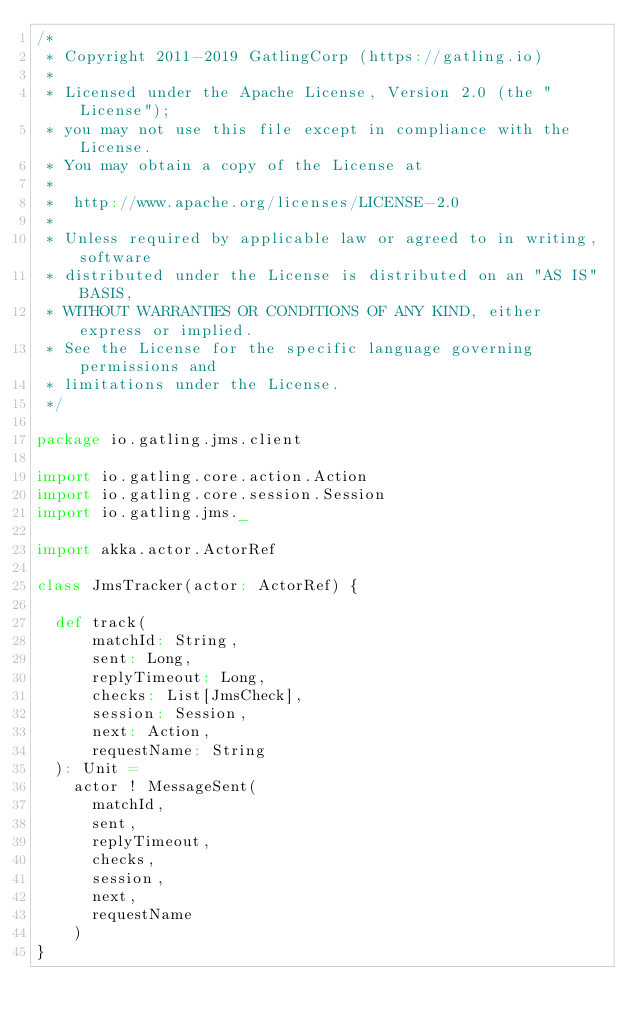<code> <loc_0><loc_0><loc_500><loc_500><_Scala_>/*
 * Copyright 2011-2019 GatlingCorp (https://gatling.io)
 *
 * Licensed under the Apache License, Version 2.0 (the "License");
 * you may not use this file except in compliance with the License.
 * You may obtain a copy of the License at
 *
 *  http://www.apache.org/licenses/LICENSE-2.0
 *
 * Unless required by applicable law or agreed to in writing, software
 * distributed under the License is distributed on an "AS IS" BASIS,
 * WITHOUT WARRANTIES OR CONDITIONS OF ANY KIND, either express or implied.
 * See the License for the specific language governing permissions and
 * limitations under the License.
 */

package io.gatling.jms.client

import io.gatling.core.action.Action
import io.gatling.core.session.Session
import io.gatling.jms._

import akka.actor.ActorRef

class JmsTracker(actor: ActorRef) {

  def track(
      matchId: String,
      sent: Long,
      replyTimeout: Long,
      checks: List[JmsCheck],
      session: Session,
      next: Action,
      requestName: String
  ): Unit =
    actor ! MessageSent(
      matchId,
      sent,
      replyTimeout,
      checks,
      session,
      next,
      requestName
    )
}
</code> 